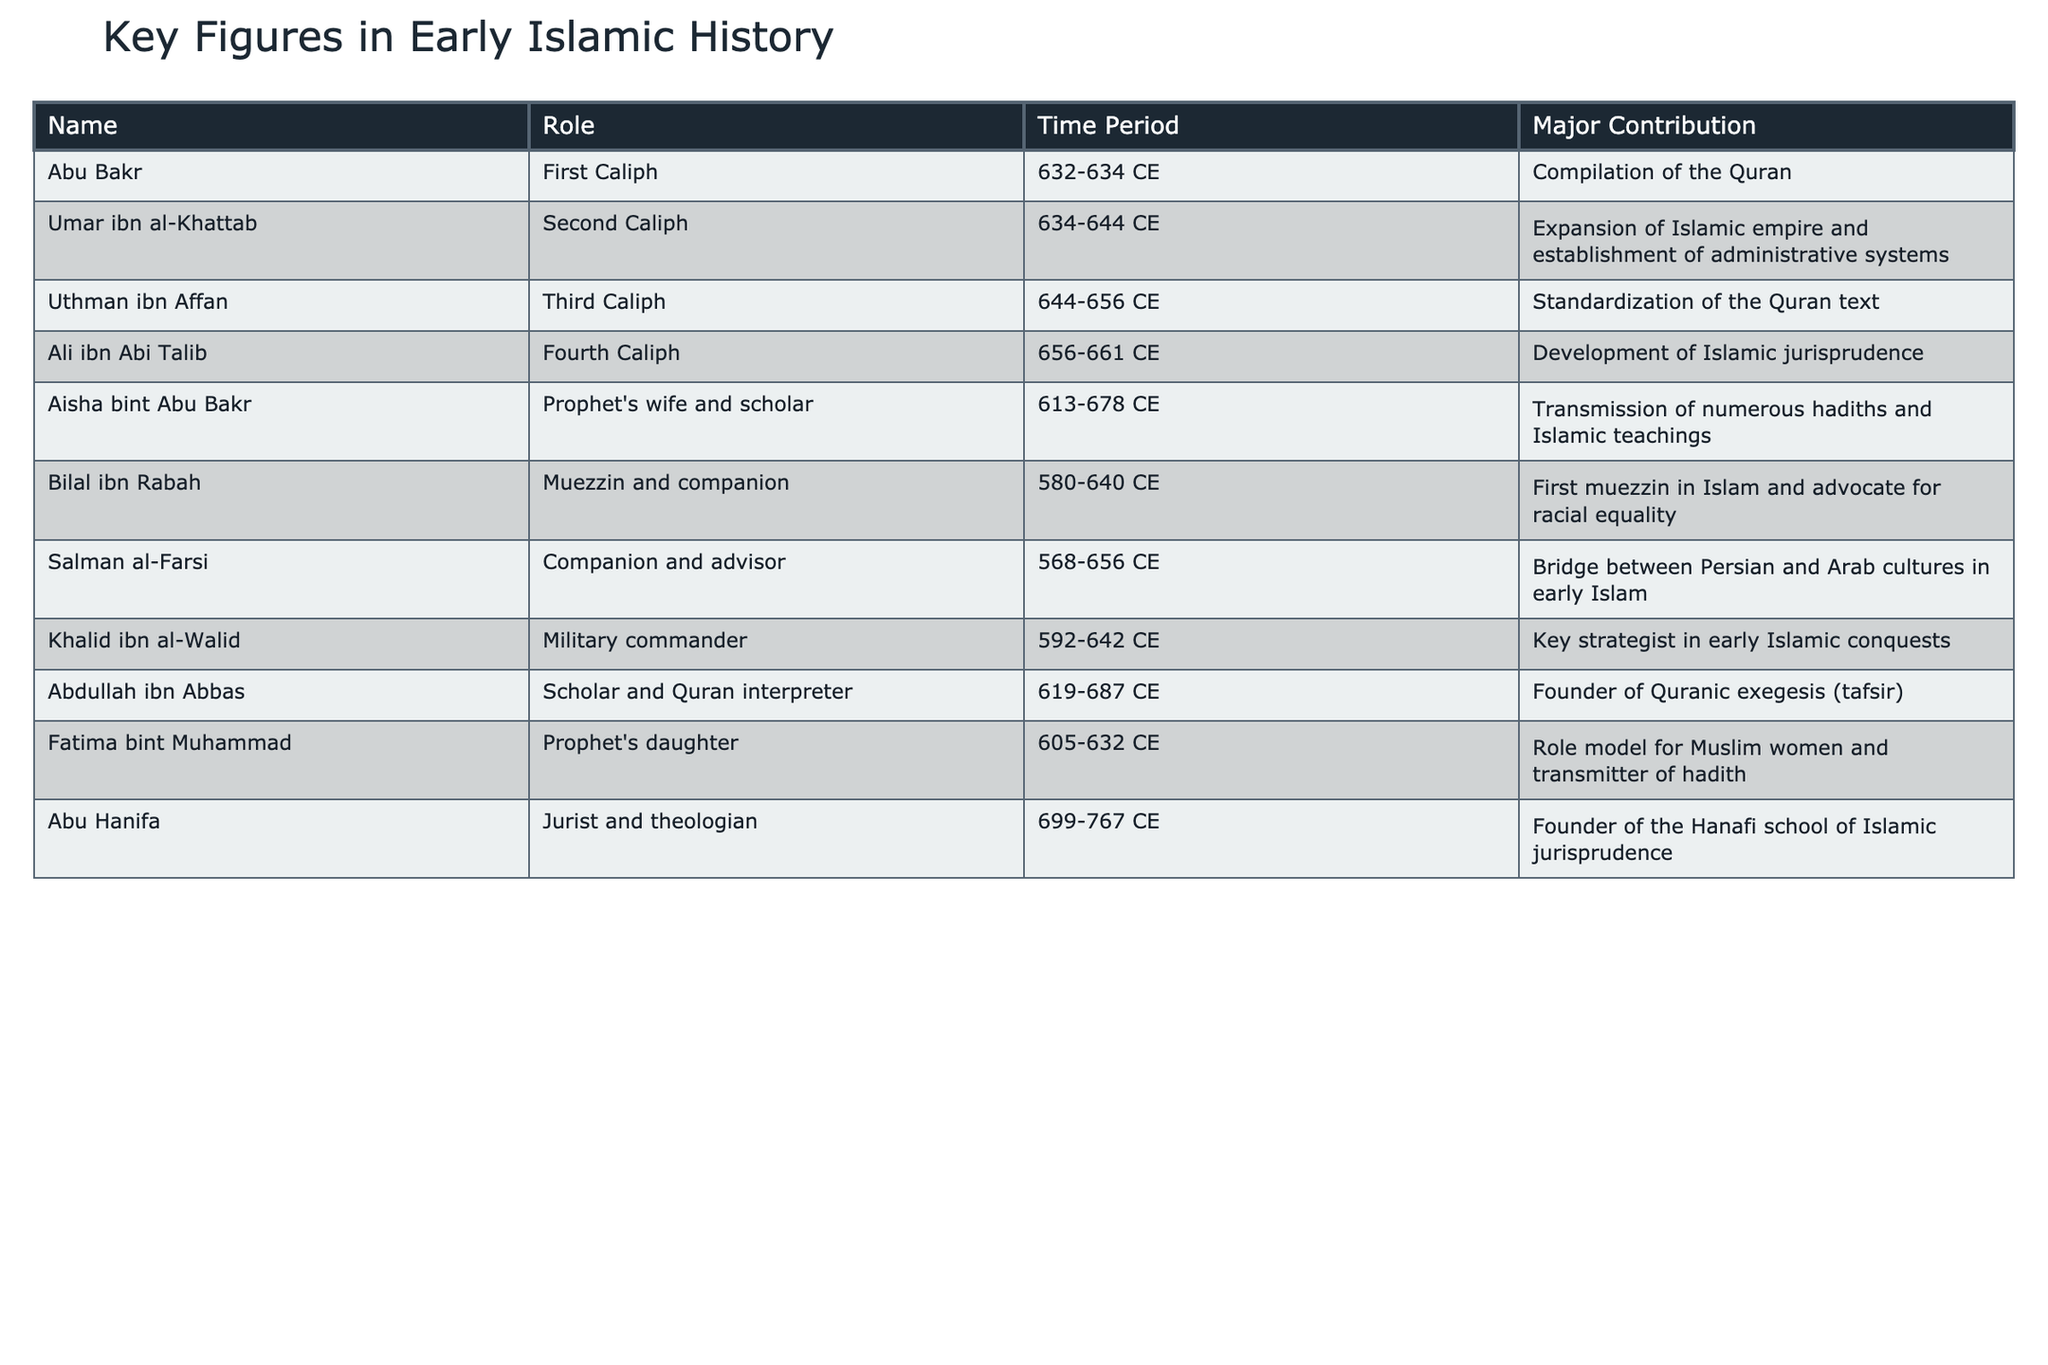What major contribution did Umar ibn al-Khattab make? Umar ibn al-Khattab was a significant figure in early Islamic history, serving as the Second Caliph from 634 to 644 CE, during which he expanded the Islamic empire and established administrative systems. This information can be found directly in the table.
Answer: Expansion of Islamic empire and establishment of administrative systems Who was the first muezzin in Islam? The table indicates that Bilal ibn Rabah served as the first muezzin in Islam. This role is explicitly stated in the data listing under his contribution.
Answer: Bilal ibn Rabah How many years did Ali ibn Abi Talib serve as Caliph? Ali ibn Abi Talib served as the Fourth Caliph from 656 to 661 CE. To determine the length of his service, we subtract the start year from the end year: 661 - 656 = 5 years.
Answer: 5 years Which key figure is known for the role model for Muslim women? The table shows that Fatima bint Muhammad, the Prophet's daughter, is recognized for being a role model for Muslim women. This detail is explicitly mentioned in her contribution in the table.
Answer: Fatima bint Muhammad Did Aisha bint Abu Bakr contribute to Islamic teachings? Yes, the data clearly states that Aisha bint Abu Bakr transmitted numerous hadiths and Islamic teachings, confirming her significant contribution.
Answer: Yes Which two figures contributed to the standardization and compilation of the Quran? The table reveals that Uthman ibn Affan is known for the standardization of the Quran text, and Abu Bakr contributed to the compilation of the Quran. This analysis requires looking at both contributions listed in the table.
Answer: Uthman ibn Affan and Abu Bakr What was the time period during which Abu Hanifa lived? By examining the table, we find that Abu Hanifa lived from 699 to 767 CE. This time frame is directly provided in the data.
Answer: 699-767 CE Compare the time periods of Aisha bint Abu Bakr and Abdullah ibn Abbas. Who lived longer? Aisha bint Abu Bakr lived from 613 to 678 CE (65 years), while Abdullah ibn Abbas lived from 619 to 687 CE (68 years). Therefore, we can determine that Abdullah ibn Abbas lived longer by comparing the lengths of their lives using the provided time periods in the table.
Answer: Abdullah ibn Abbas What role did Salman al-Farsi play in early Islam? The table indicates that Salman al-Farsi served as a companion and advisor, providing a bridge between Persian and Arab cultures in early Islam. This information is clearly stated in the contribution.
Answer: Companion and advisor How many figures served as Caliphs according to the table? The table lists four figures designated as Caliphs: Abu Bakr, Umar ibn al-Khattab, Uthman ibn Affan, and Ali ibn Abi Talib. Counting these entries confirms that there are four individuals in this role.
Answer: 4 figures 